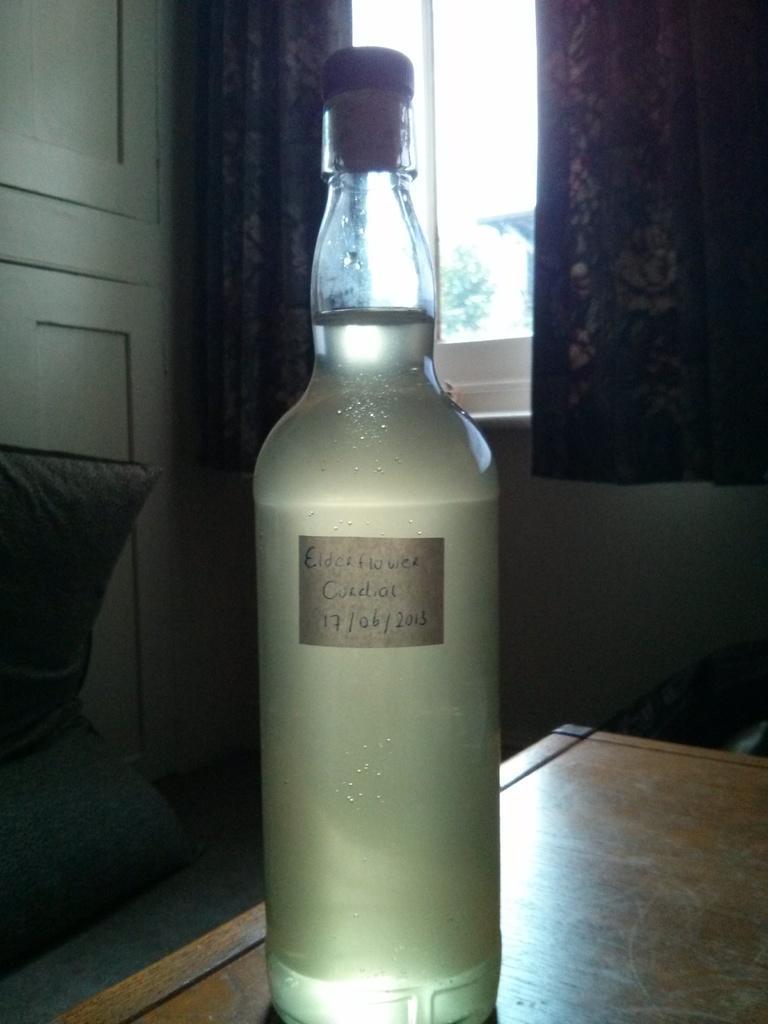How would you summarize this image in a sentence or two? In this image I can see a bottle on the table. And I can also see a window and curtain to the wall. 